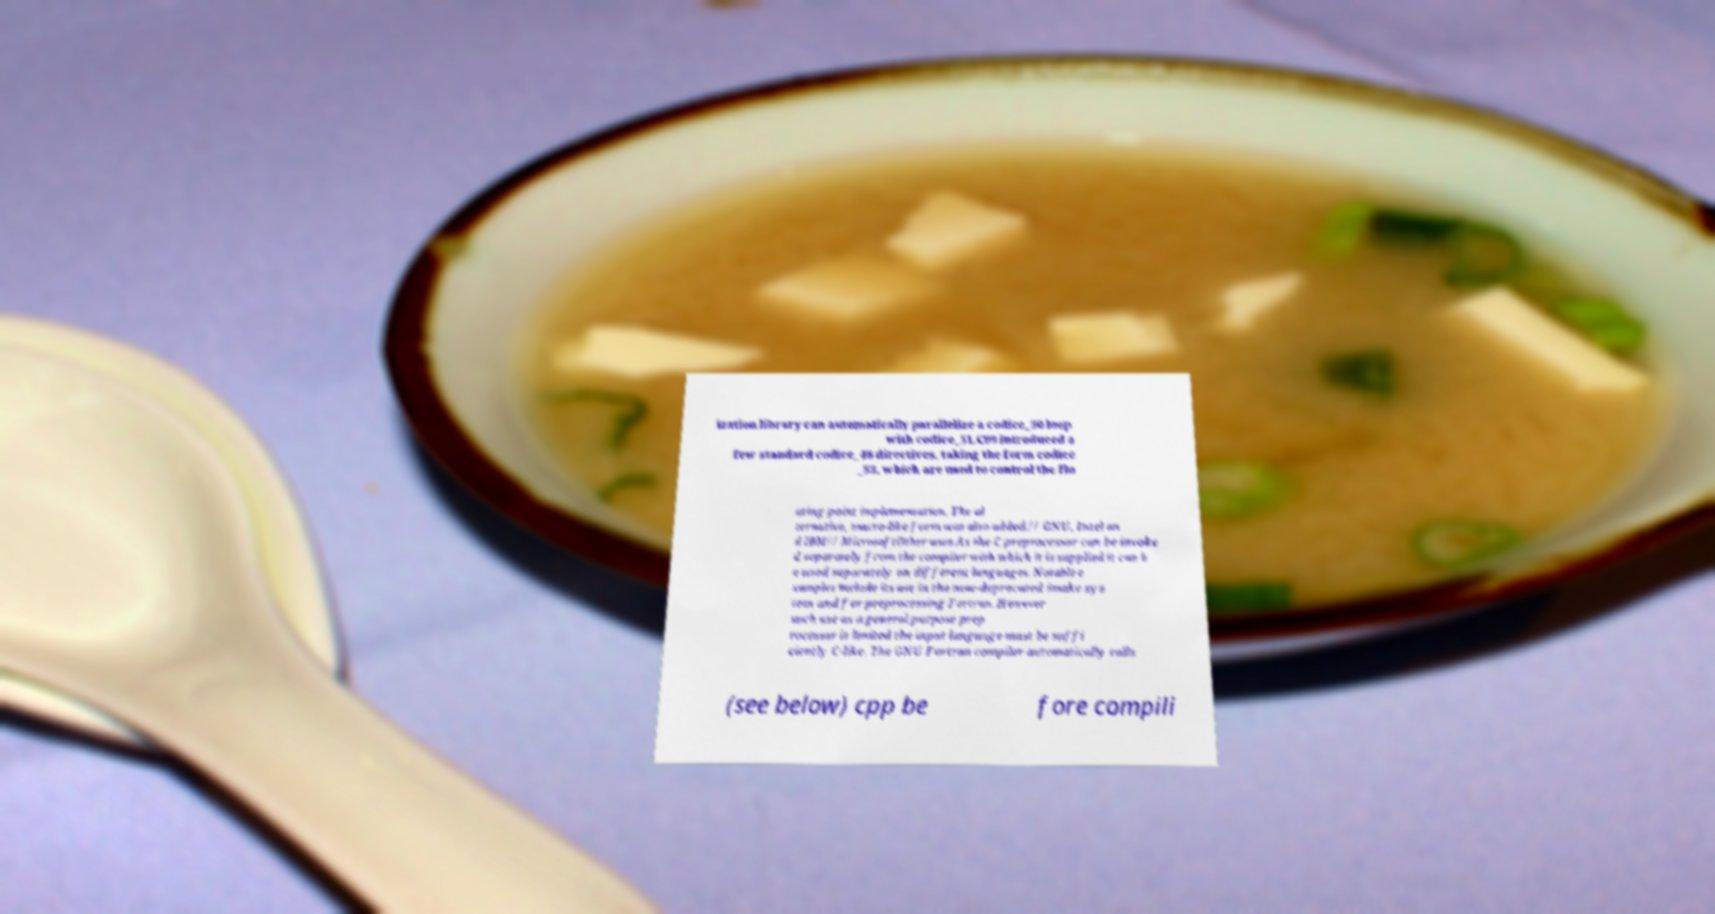Could you assist in decoding the text presented in this image and type it out clearly? ization library can automatically parallelize a codice_50 loop with codice_51.C99 introduced a few standard codice_48 directives, taking the form codice _53, which are used to control the flo ating-point implementation. The al ternative, macro-like form was also added.// GNU, Intel an d IBM// MicrosoftOther uses.As the C preprocessor can be invoke d separately from the compiler with which it is supplied it can b e used separately on different languages. Notable e xamples include its use in the now-deprecated imake sys tem and for preprocessing Fortran. However such use as a general purpose prep rocessor is limited the input language must be suffi ciently C-like. The GNU Fortran compiler automatically calls (see below) cpp be fore compili 